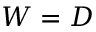<formula> <loc_0><loc_0><loc_500><loc_500>W = D</formula> 